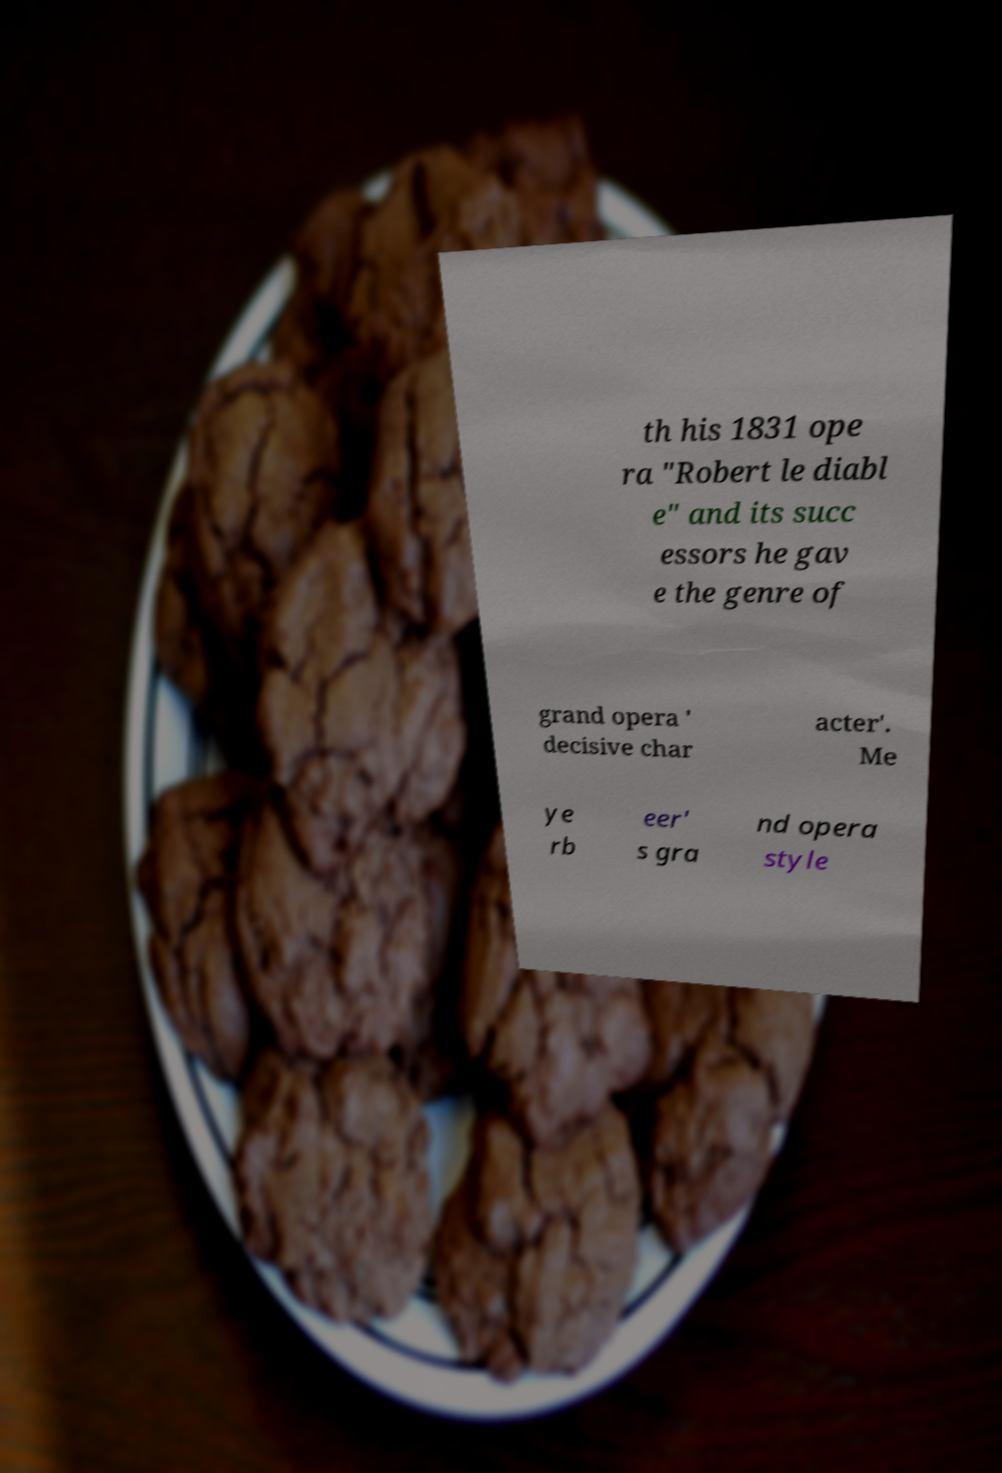Could you assist in decoding the text presented in this image and type it out clearly? th his 1831 ope ra "Robert le diabl e" and its succ essors he gav e the genre of grand opera ' decisive char acter'. Me ye rb eer' s gra nd opera style 